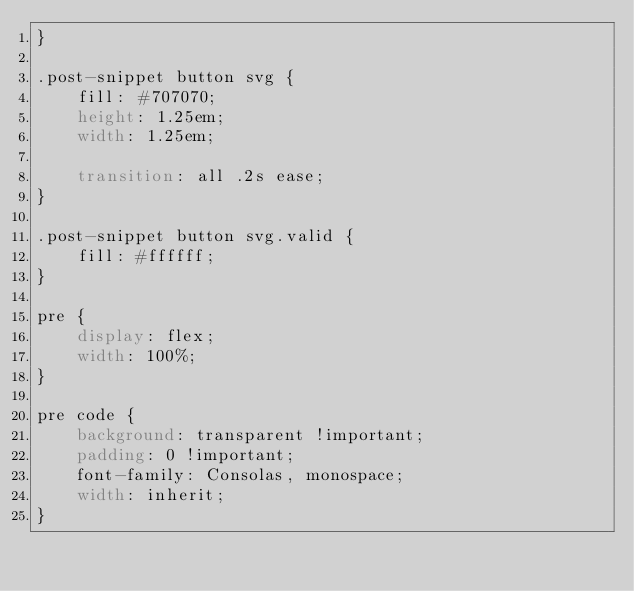Convert code to text. <code><loc_0><loc_0><loc_500><loc_500><_CSS_>}

.post-snippet button svg {
    fill: #707070;
    height: 1.25em;
    width: 1.25em;

    transition: all .2s ease;
}

.post-snippet button svg.valid {
    fill: #ffffff;
}

pre {
    display: flex;
    width: 100%;
}

pre code {
    background: transparent !important;
    padding: 0 !important;
    font-family: Consolas, monospace;
    width: inherit;
}
</code> 